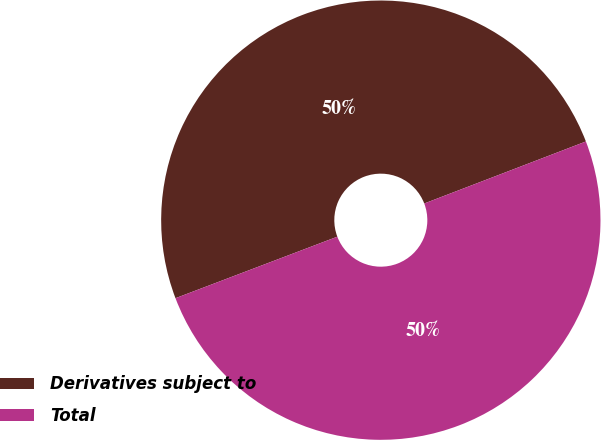Convert chart to OTSL. <chart><loc_0><loc_0><loc_500><loc_500><pie_chart><fcel>Derivatives subject to<fcel>Total<nl><fcel>49.95%<fcel>50.05%<nl></chart> 